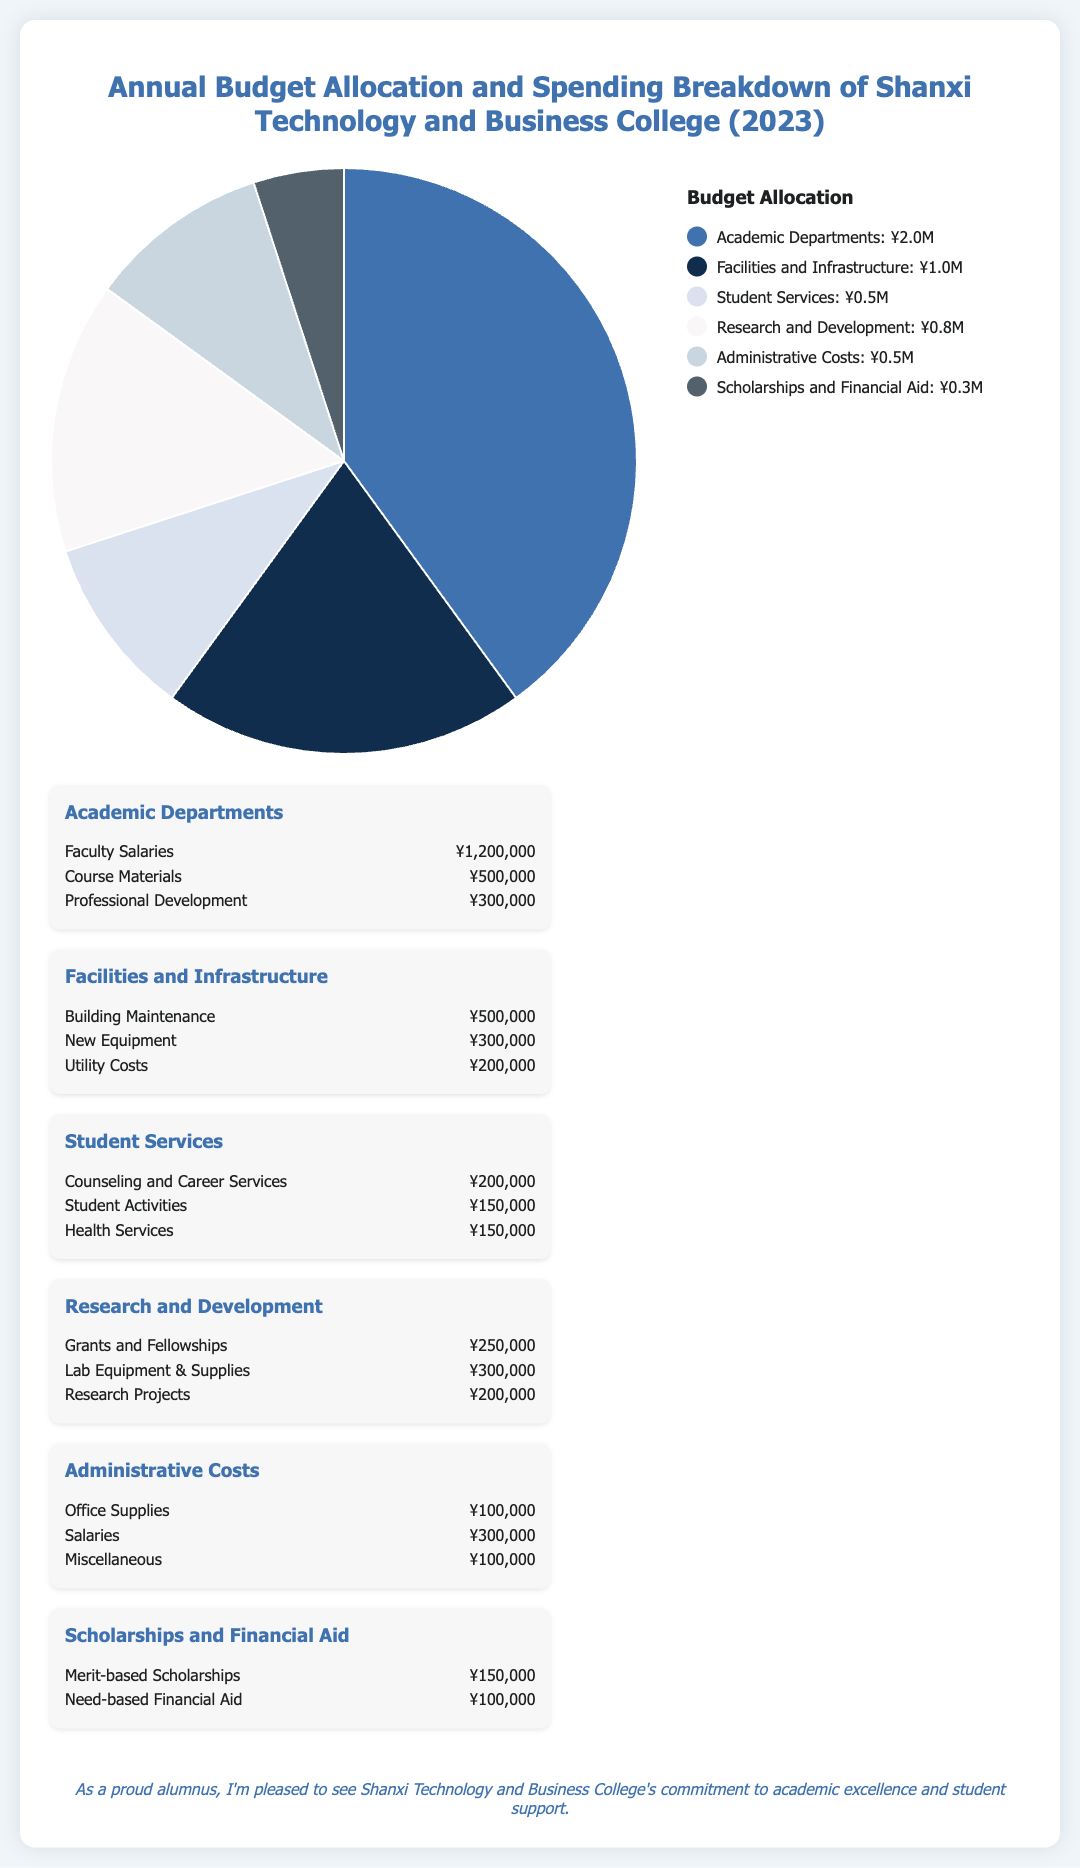What was the total budget allocation for Academic Departments? The total budget allocation for Academic Departments is ¥2,000,000.
Answer: ¥2,000,000 How much is allocated for Research and Development? The budget allocated for Research and Development is ¥750,000.
Answer: ¥750,000 What category has the lowest spending in the breakdown? The category with the lowest spending is Scholarships and Financial Aid.
Answer: Scholarships and Financial Aid What is the total spending on Faculty Salaries? The total spending on Faculty Salaries is ¥1,200,000.
Answer: ¥1,200,000 How much is budgeted for New Equipment? The budget for New Equipment is ¥300,000.
Answer: ¥300,000 Which spending category focuses on student-related services? The spending category that focuses on student-related services is Student Services.
Answer: Student Services What is the combined spending on Building Maintenance and Utility Costs? The combined spending on Building Maintenance (¥500,000) and Utility Costs (¥200,000) totals ¥700,000.
Answer: ¥700,000 How many spending categories are listed in the infographic? There are six spending categories listed in the infographic.
Answer: Six What is the total spending amount for Administrative Costs? The total spending amount for Administrative Costs is ¥500,000.
Answer: ¥500,000 